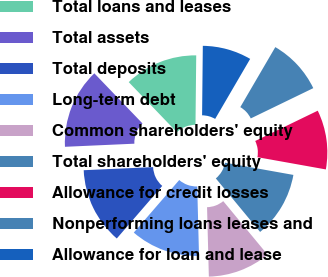Convert chart. <chart><loc_0><loc_0><loc_500><loc_500><pie_chart><fcel>Total loans and leases<fcel>Total assets<fcel>Total deposits<fcel>Long-term debt<fcel>Common shareholders' equity<fcel>Total shareholders' equity<fcel>Allowance for credit losses<fcel>Nonperforming loans leases and<fcel>Allowance for loan and lease<nl><fcel>12.35%<fcel>13.53%<fcel>12.94%<fcel>11.76%<fcel>10.59%<fcel>11.18%<fcel>10.0%<fcel>9.41%<fcel>8.24%<nl></chart> 